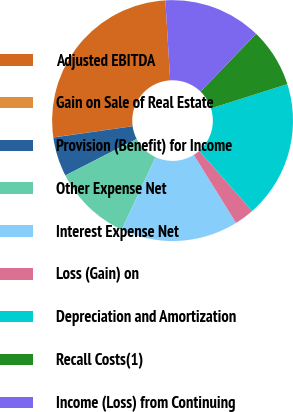Convert chart. <chart><loc_0><loc_0><loc_500><loc_500><pie_chart><fcel>Adjusted EBITDA<fcel>Gain on Sale of Real Estate<fcel>Provision (Benefit) for Income<fcel>Other Expense Net<fcel>Interest Expense Net<fcel>Loss (Gain) on<fcel>Depreciation and Amortization<fcel>Recall Costs(1)<fcel>Income (Loss) from Continuing<nl><fcel>26.28%<fcel>0.02%<fcel>5.28%<fcel>10.53%<fcel>15.78%<fcel>2.65%<fcel>18.41%<fcel>7.9%<fcel>13.15%<nl></chart> 